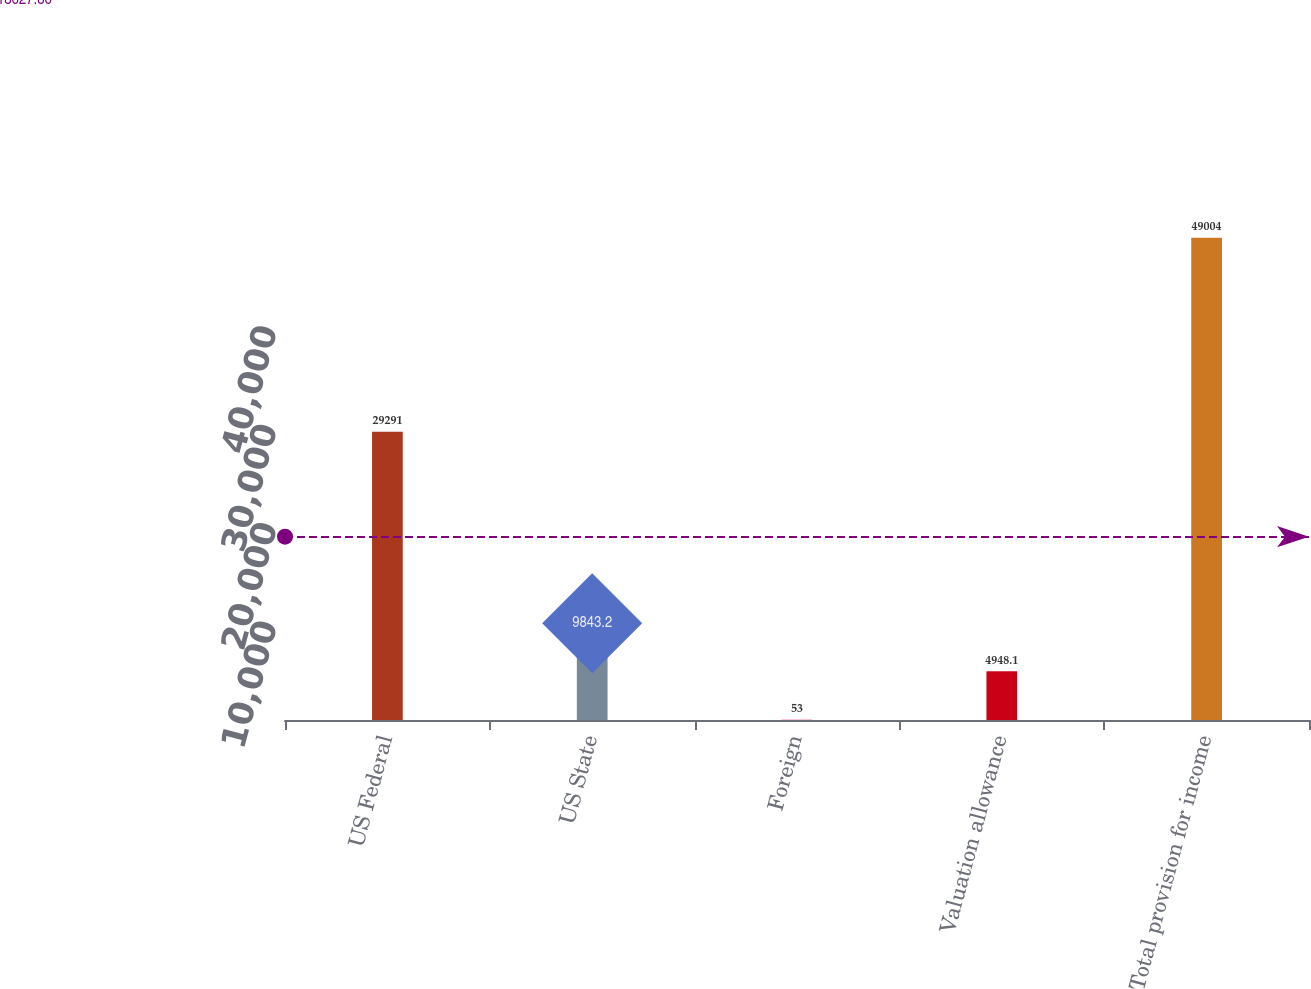Convert chart to OTSL. <chart><loc_0><loc_0><loc_500><loc_500><bar_chart><fcel>US Federal<fcel>US State<fcel>Foreign<fcel>Valuation allowance<fcel>Total provision for income<nl><fcel>29291<fcel>9843.2<fcel>53<fcel>4948.1<fcel>49004<nl></chart> 